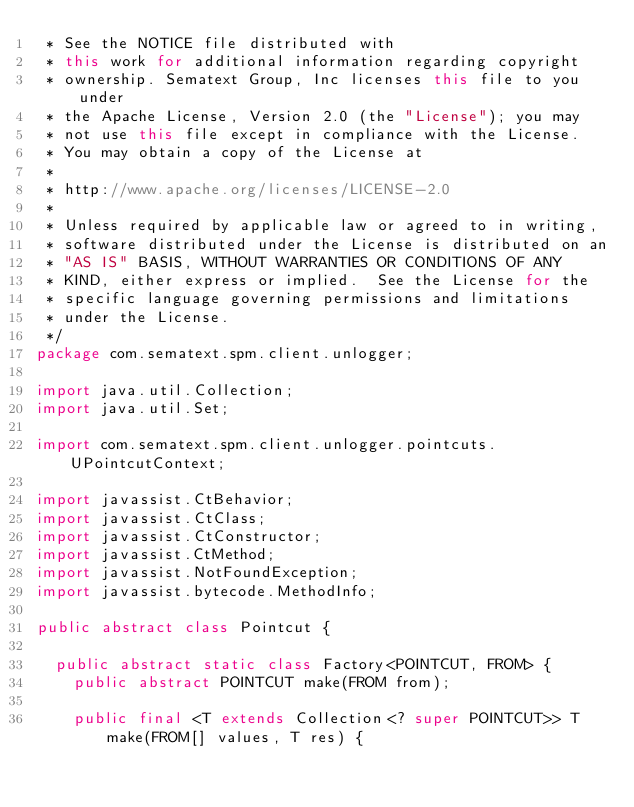<code> <loc_0><loc_0><loc_500><loc_500><_Java_> * See the NOTICE file distributed with
 * this work for additional information regarding copyright
 * ownership. Sematext Group, Inc licenses this file to you under
 * the Apache License, Version 2.0 (the "License"); you may
 * not use this file except in compliance with the License.
 * You may obtain a copy of the License at
 *
 * http://www.apache.org/licenses/LICENSE-2.0
 *
 * Unless required by applicable law or agreed to in writing,
 * software distributed under the License is distributed on an
 * "AS IS" BASIS, WITHOUT WARRANTIES OR CONDITIONS OF ANY
 * KIND, either express or implied.  See the License for the
 * specific language governing permissions and limitations
 * under the License.
 */
package com.sematext.spm.client.unlogger;

import java.util.Collection;
import java.util.Set;

import com.sematext.spm.client.unlogger.pointcuts.UPointcutContext;

import javassist.CtBehavior;
import javassist.CtClass;
import javassist.CtConstructor;
import javassist.CtMethod;
import javassist.NotFoundException;
import javassist.bytecode.MethodInfo;

public abstract class Pointcut {

  public abstract static class Factory<POINTCUT, FROM> {
    public abstract POINTCUT make(FROM from);

    public final <T extends Collection<? super POINTCUT>> T make(FROM[] values, T res) {</code> 